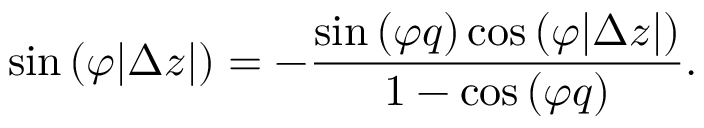Convert formula to latex. <formula><loc_0><loc_0><loc_500><loc_500>\sin { ( \varphi | \Delta z | ) } = - \frac { \sin { ( \varphi q ) } \cos { ( \varphi | \Delta z | ) } } { 1 - \cos { ( \varphi q ) } } .</formula> 